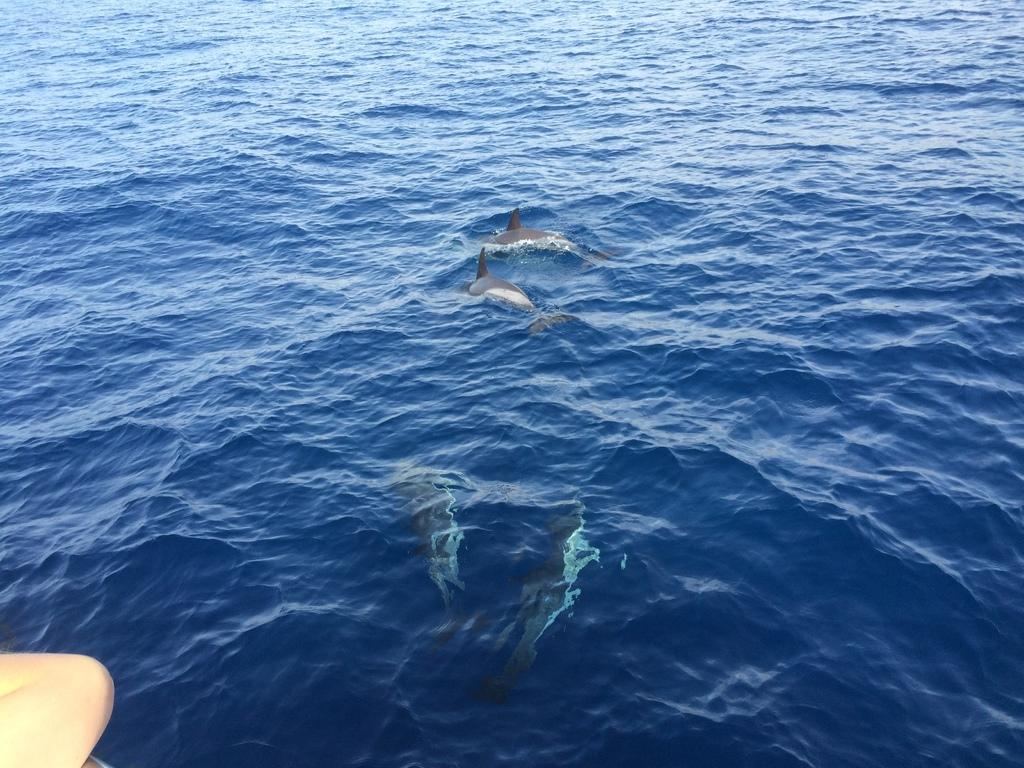What animals are present in the image? There are dolphins in the image. Where are the dolphins located? The dolphins are in a river. Can you describe any human presence in the image? There is a hand of a person at the bottom left side of the image. What effect does the drain have on the dolphins in the image? There is no drain present in the image, so it cannot have any effect on the dolphins. 